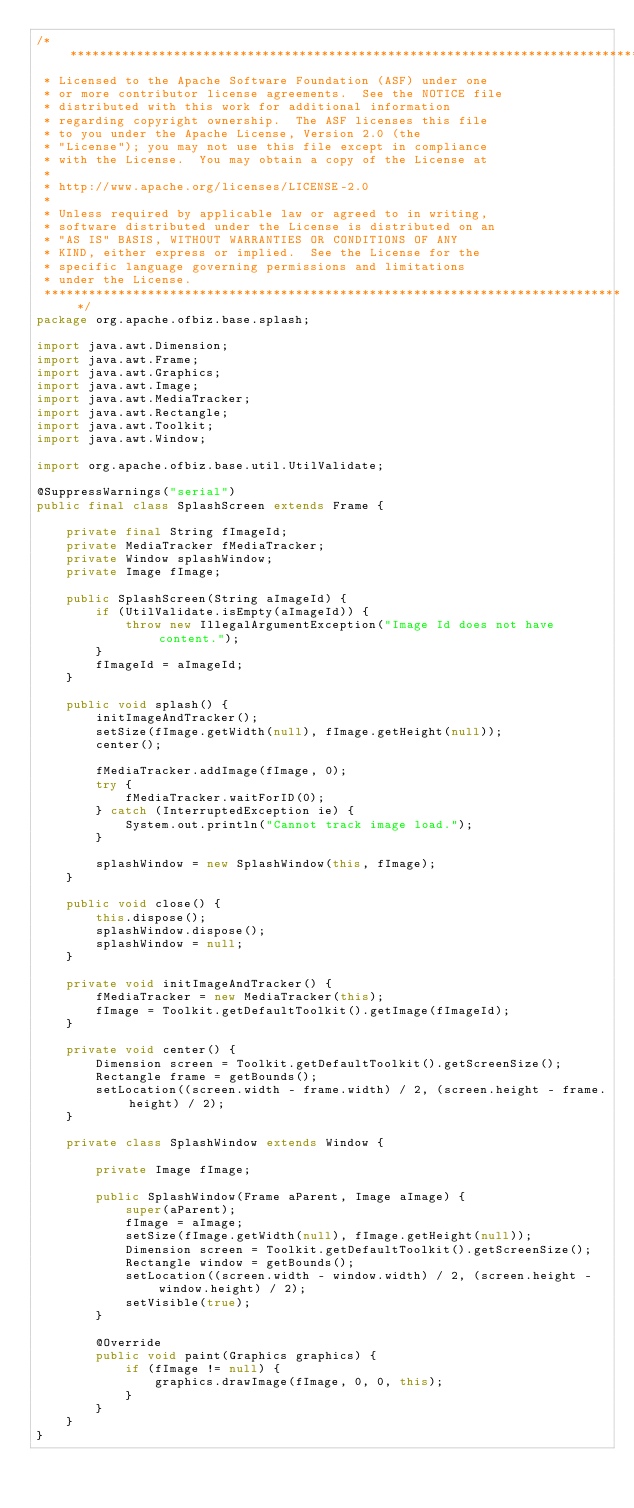Convert code to text. <code><loc_0><loc_0><loc_500><loc_500><_Java_>/*******************************************************************************
 * Licensed to the Apache Software Foundation (ASF) under one
 * or more contributor license agreements.  See the NOTICE file
 * distributed with this work for additional information
 * regarding copyright ownership.  The ASF licenses this file
 * to you under the Apache License, Version 2.0 (the
 * "License"); you may not use this file except in compliance
 * with the License.  You may obtain a copy of the License at
 *
 * http://www.apache.org/licenses/LICENSE-2.0
 *
 * Unless required by applicable law or agreed to in writing,
 * software distributed under the License is distributed on an
 * "AS IS" BASIS, WITHOUT WARRANTIES OR CONDITIONS OF ANY
 * KIND, either express or implied.  See the License for the
 * specific language governing permissions and limitations
 * under the License.
 *******************************************************************************/
package org.apache.ofbiz.base.splash;

import java.awt.Dimension;
import java.awt.Frame;
import java.awt.Graphics;
import java.awt.Image;
import java.awt.MediaTracker;
import java.awt.Rectangle;
import java.awt.Toolkit;
import java.awt.Window;

import org.apache.ofbiz.base.util.UtilValidate;

@SuppressWarnings("serial")
public final class SplashScreen extends Frame {

    private final String fImageId;
    private MediaTracker fMediaTracker;
    private Window splashWindow;
    private Image fImage;

    public SplashScreen(String aImageId) {
        if (UtilValidate.isEmpty(aImageId)) {
            throw new IllegalArgumentException("Image Id does not have content.");
        }
        fImageId = aImageId;
    }

    public void splash() {
        initImageAndTracker();
        setSize(fImage.getWidth(null), fImage.getHeight(null));
        center();

        fMediaTracker.addImage(fImage, 0);
        try {
            fMediaTracker.waitForID(0);
        } catch (InterruptedException ie) {
            System.out.println("Cannot track image load.");
        }

        splashWindow = new SplashWindow(this, fImage);
    }

    public void close() {
        this.dispose();
        splashWindow.dispose();
        splashWindow = null;
    }

    private void initImageAndTracker() {
        fMediaTracker = new MediaTracker(this);
        fImage = Toolkit.getDefaultToolkit().getImage(fImageId);
    }

    private void center() {
        Dimension screen = Toolkit.getDefaultToolkit().getScreenSize();
        Rectangle frame = getBounds();
        setLocation((screen.width - frame.width) / 2, (screen.height - frame.height) / 2);
    }

    private class SplashWindow extends Window {

        private Image fImage;

        public SplashWindow(Frame aParent, Image aImage) {
            super(aParent);
            fImage = aImage;
            setSize(fImage.getWidth(null), fImage.getHeight(null));
            Dimension screen = Toolkit.getDefaultToolkit().getScreenSize();
            Rectangle window = getBounds();
            setLocation((screen.width - window.width) / 2, (screen.height - window.height) / 2);
            setVisible(true);
        }

        @Override
        public void paint(Graphics graphics) {
            if (fImage != null) {
                graphics.drawImage(fImage, 0, 0, this);
            }
        }
    }
}
</code> 